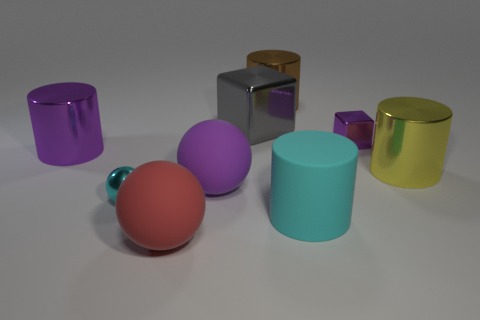Are there fewer small cyan balls that are to the left of the cyan shiny ball than big red metal objects?
Provide a succinct answer. No. What number of large things are red balls or brown matte balls?
Give a very brief answer. 1. How big is the yellow thing?
Make the answer very short. Large. There is a big cyan cylinder; what number of big objects are on the left side of it?
Give a very brief answer. 5. There is another object that is the same shape as the tiny purple thing; what size is it?
Keep it short and to the point. Large. There is a metallic thing that is to the right of the large red matte ball and in front of the purple metallic block; what size is it?
Make the answer very short. Large. There is a tiny sphere; does it have the same color as the large rubber thing that is on the right side of the purple matte object?
Offer a terse response. Yes. What number of cyan things are tiny metallic balls or small metal blocks?
Offer a very short reply. 1. What is the shape of the gray thing?
Ensure brevity in your answer.  Cube. What number of other things are the same shape as the cyan metallic thing?
Give a very brief answer. 2. 